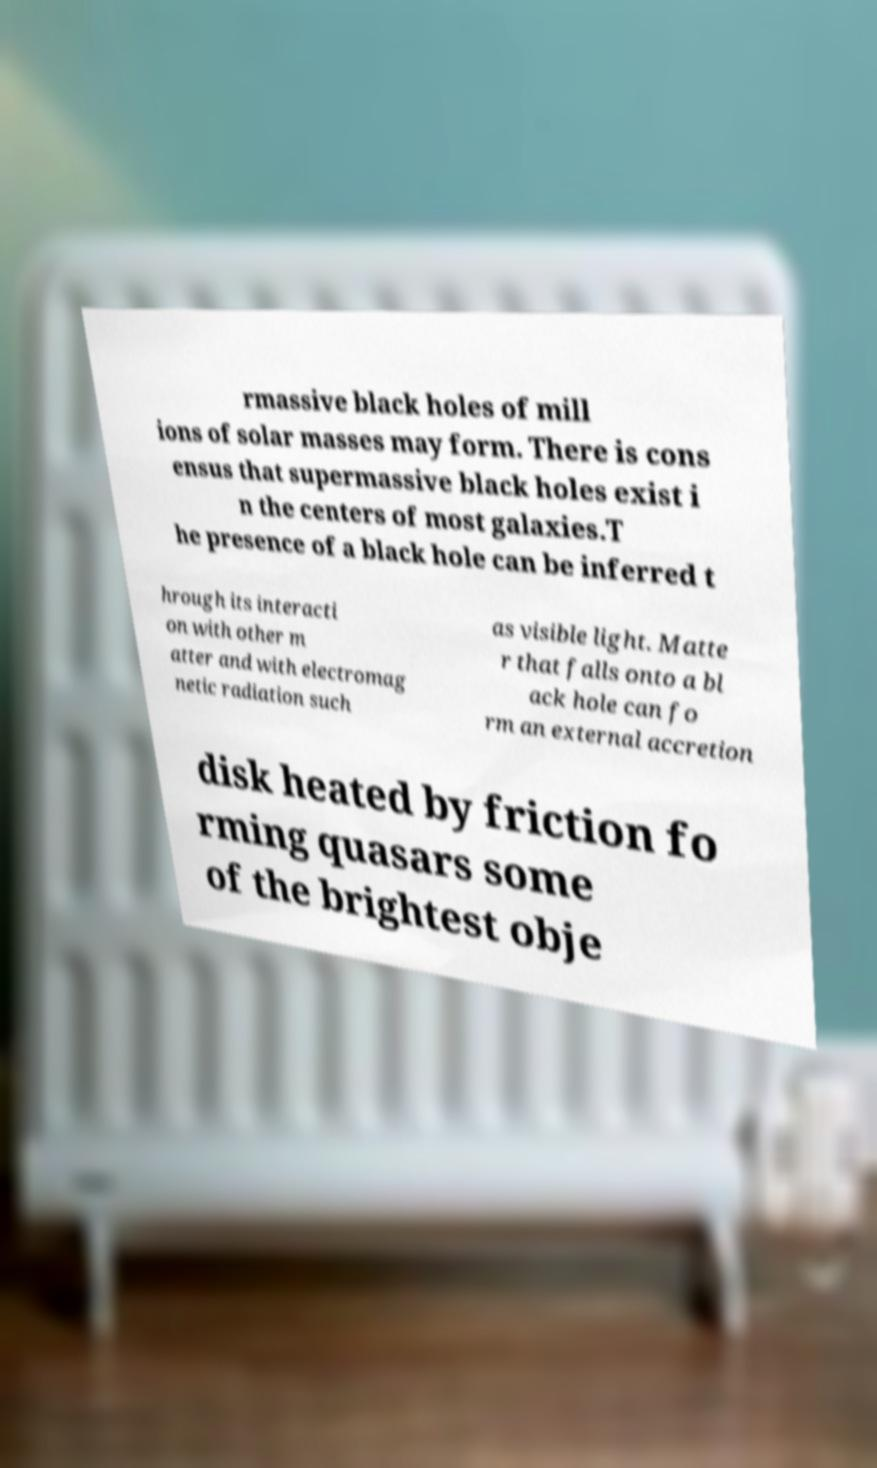Please read and relay the text visible in this image. What does it say? rmassive black holes of mill ions of solar masses may form. There is cons ensus that supermassive black holes exist i n the centers of most galaxies.T he presence of a black hole can be inferred t hrough its interacti on with other m atter and with electromag netic radiation such as visible light. Matte r that falls onto a bl ack hole can fo rm an external accretion disk heated by friction fo rming quasars some of the brightest obje 